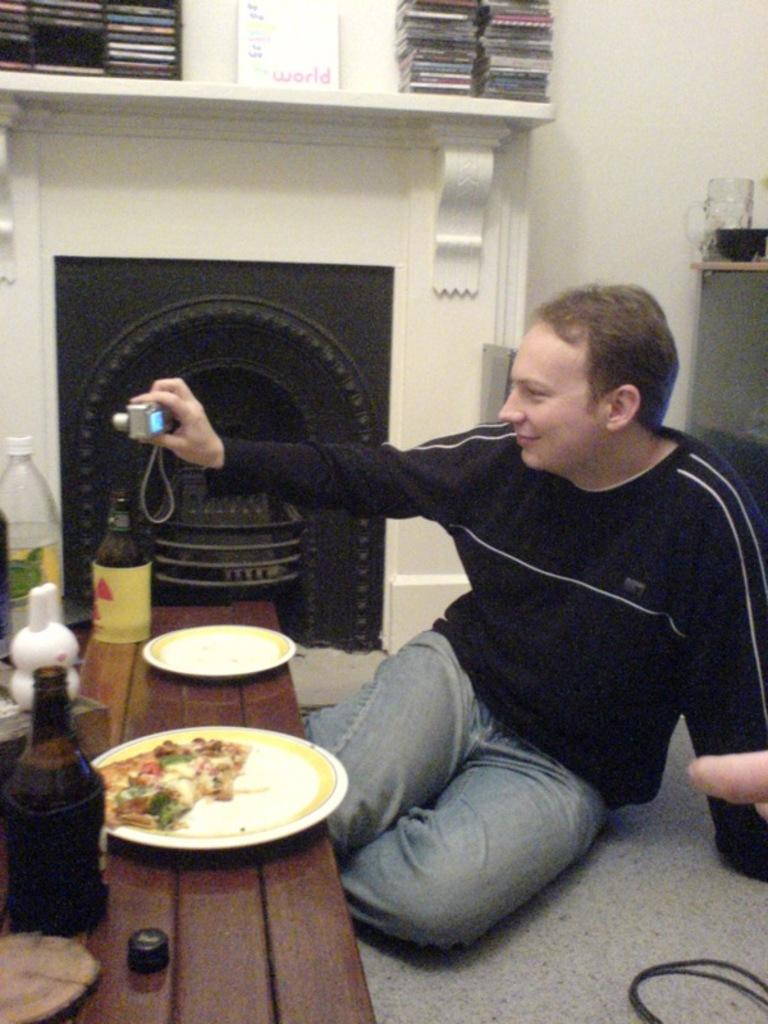<image>
Describe the image concisely. A white book with the word "world" on it sits on a mantle. 